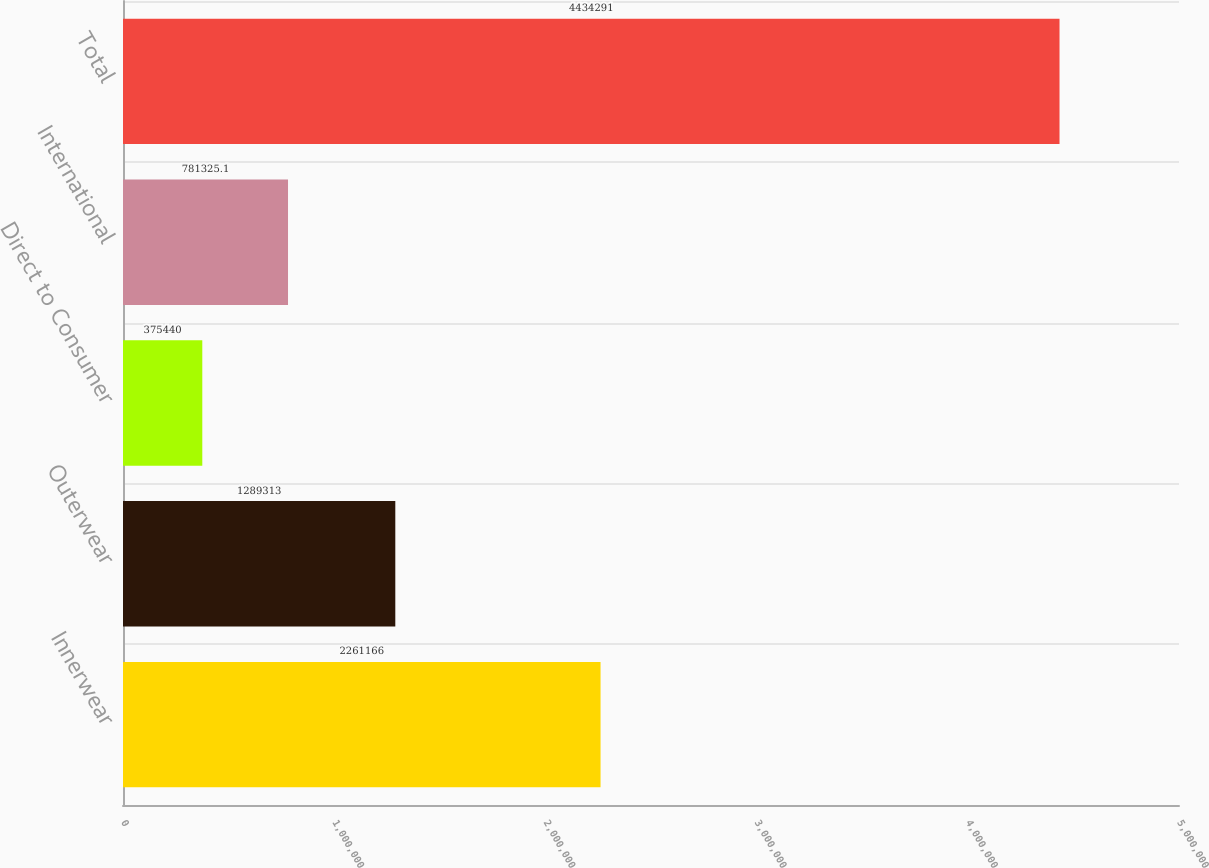Convert chart to OTSL. <chart><loc_0><loc_0><loc_500><loc_500><bar_chart><fcel>Innerwear<fcel>Outerwear<fcel>Direct to Consumer<fcel>International<fcel>Total<nl><fcel>2.26117e+06<fcel>1.28931e+06<fcel>375440<fcel>781325<fcel>4.43429e+06<nl></chart> 